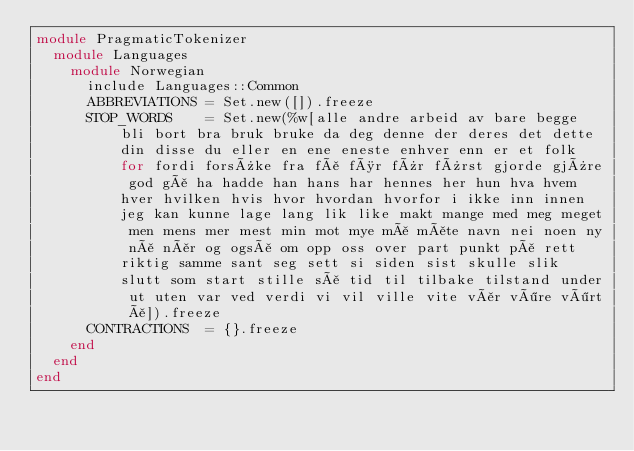<code> <loc_0><loc_0><loc_500><loc_500><_Ruby_>module PragmaticTokenizer
  module Languages
    module Norwegian
      include Languages::Common
      ABBREVIATIONS = Set.new([]).freeze
      STOP_WORDS    = Set.new(%w[alle andre arbeid av bare begge bli bort bra bruk bruke da deg denne der deres det dette din disse du eller en ene eneste enhver enn er et folk for fordi forsûke fra få før fûr fûrst gjorde gjûre god gå ha hadde han hans har hennes her hun hva hvem hver hvilken hvis hvor hvordan hvorfor i ikke inn innen jeg kan kunne lage lang lik like makt mange med meg meget men mens mer mest min mot mye må måte navn nei noen ny nå når og også om opp oss over part punkt på rett riktig samme sant seg sett si siden sist skulle slik slutt som start stille så tid til tilbake tilstand under ut uten var ved verdi vi vil ville vite vår vöre vört å]).freeze
      CONTRACTIONS  = {}.freeze
    end
  end
end
</code> 